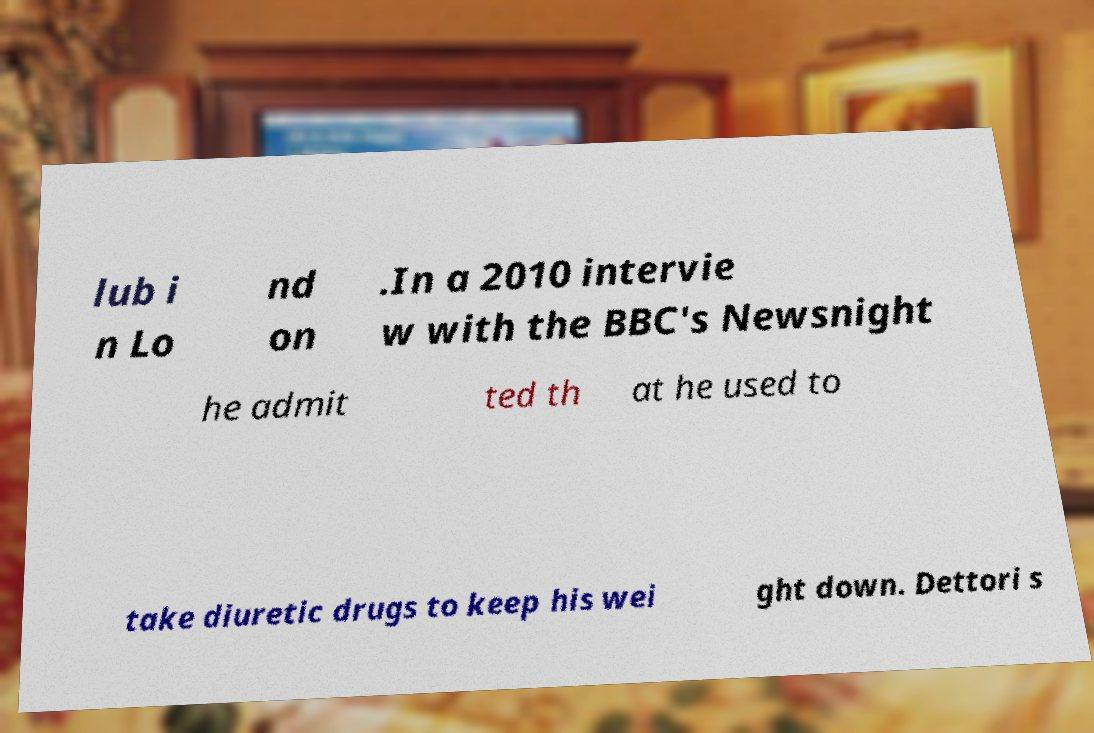What messages or text are displayed in this image? I need them in a readable, typed format. lub i n Lo nd on .In a 2010 intervie w with the BBC's Newsnight he admit ted th at he used to take diuretic drugs to keep his wei ght down. Dettori s 